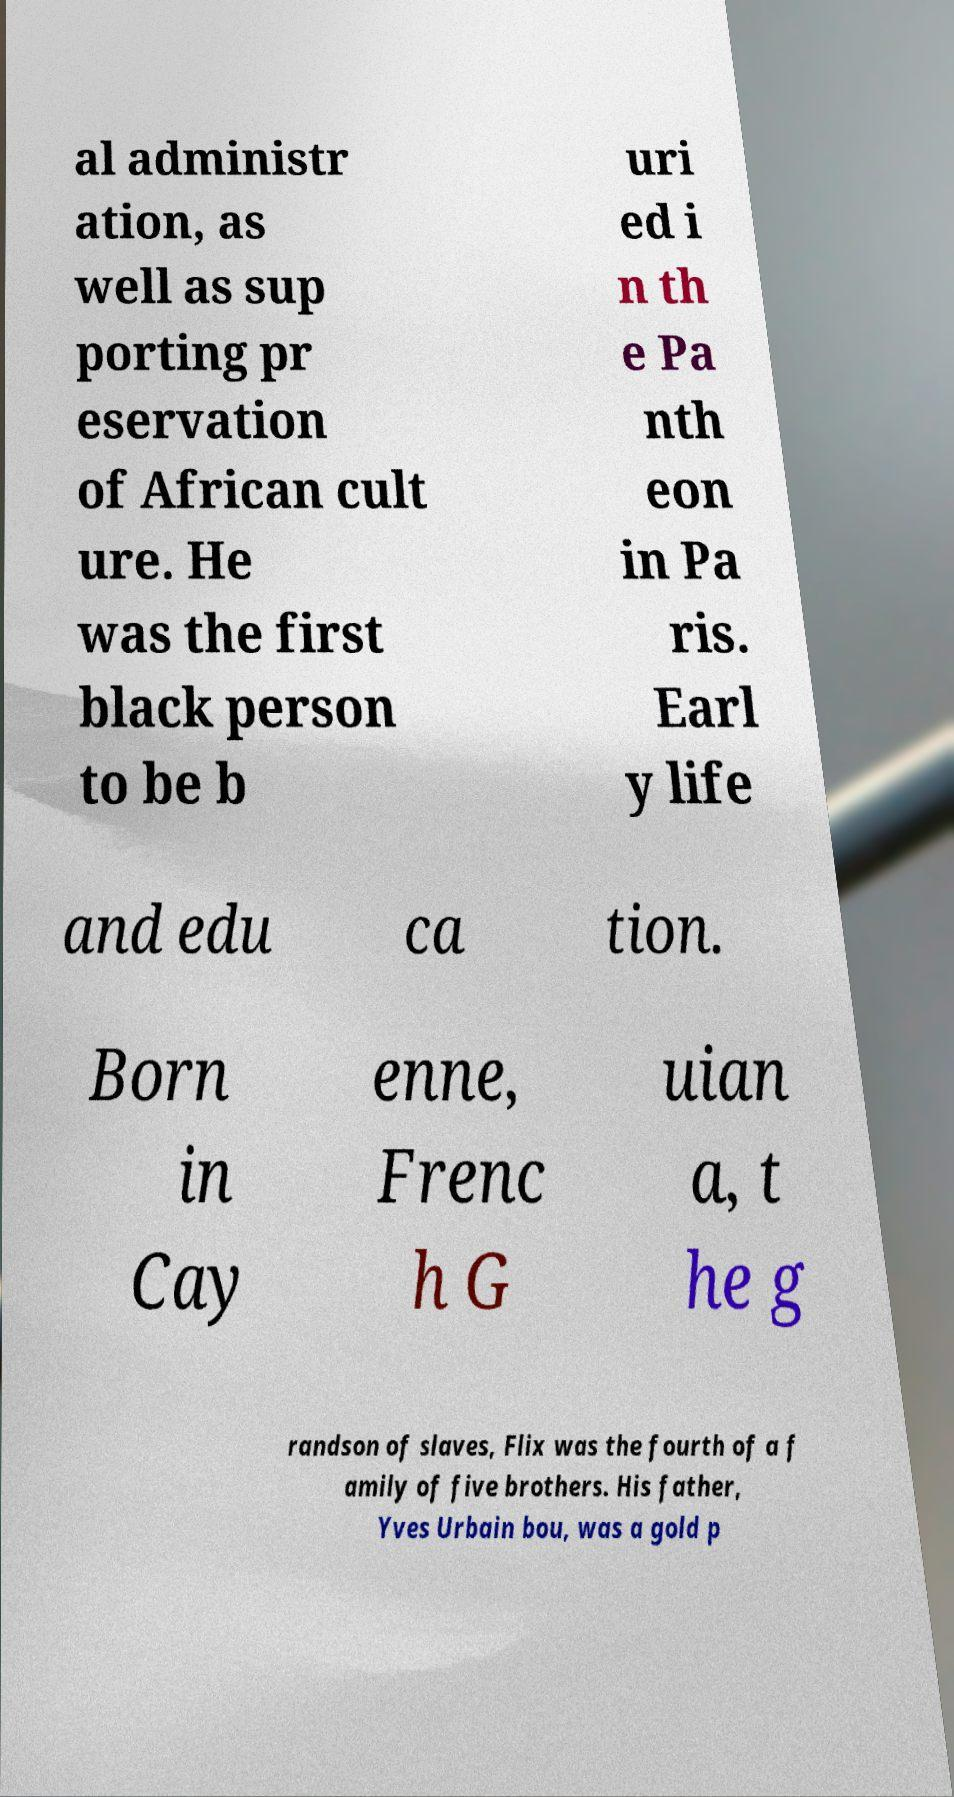Could you extract and type out the text from this image? al administr ation, as well as sup porting pr eservation of African cult ure. He was the first black person to be b uri ed i n th e Pa nth eon in Pa ris. Earl y life and edu ca tion. Born in Cay enne, Frenc h G uian a, t he g randson of slaves, Flix was the fourth of a f amily of five brothers. His father, Yves Urbain bou, was a gold p 